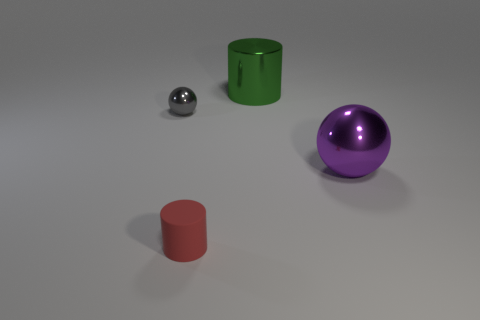Is there anything else that is the same material as the tiny gray thing?
Give a very brief answer. Yes. What is the material of the other tiny thing that is the same shape as the green metal object?
Your response must be concise. Rubber. Are there fewer cylinders that are on the left side of the small red matte cylinder than red cylinders?
Give a very brief answer. Yes. There is a green metal thing; what number of small gray objects are in front of it?
Your answer should be very brief. 1. There is a tiny thing that is behind the red matte cylinder; is it the same shape as the big metal thing that is in front of the small gray metal object?
Offer a terse response. Yes. What is the shape of the metal thing that is on the right side of the small red matte cylinder and in front of the green metal thing?
Ensure brevity in your answer.  Sphere. There is a green object that is the same material as the big purple sphere; what size is it?
Your response must be concise. Large. Are there fewer big purple objects than tiny objects?
Your answer should be compact. Yes. What material is the ball that is in front of the shiny ball on the left side of the cylinder behind the big purple ball made of?
Provide a succinct answer. Metal. Does the cylinder that is behind the rubber cylinder have the same material as the large thing in front of the green object?
Your answer should be very brief. Yes. 